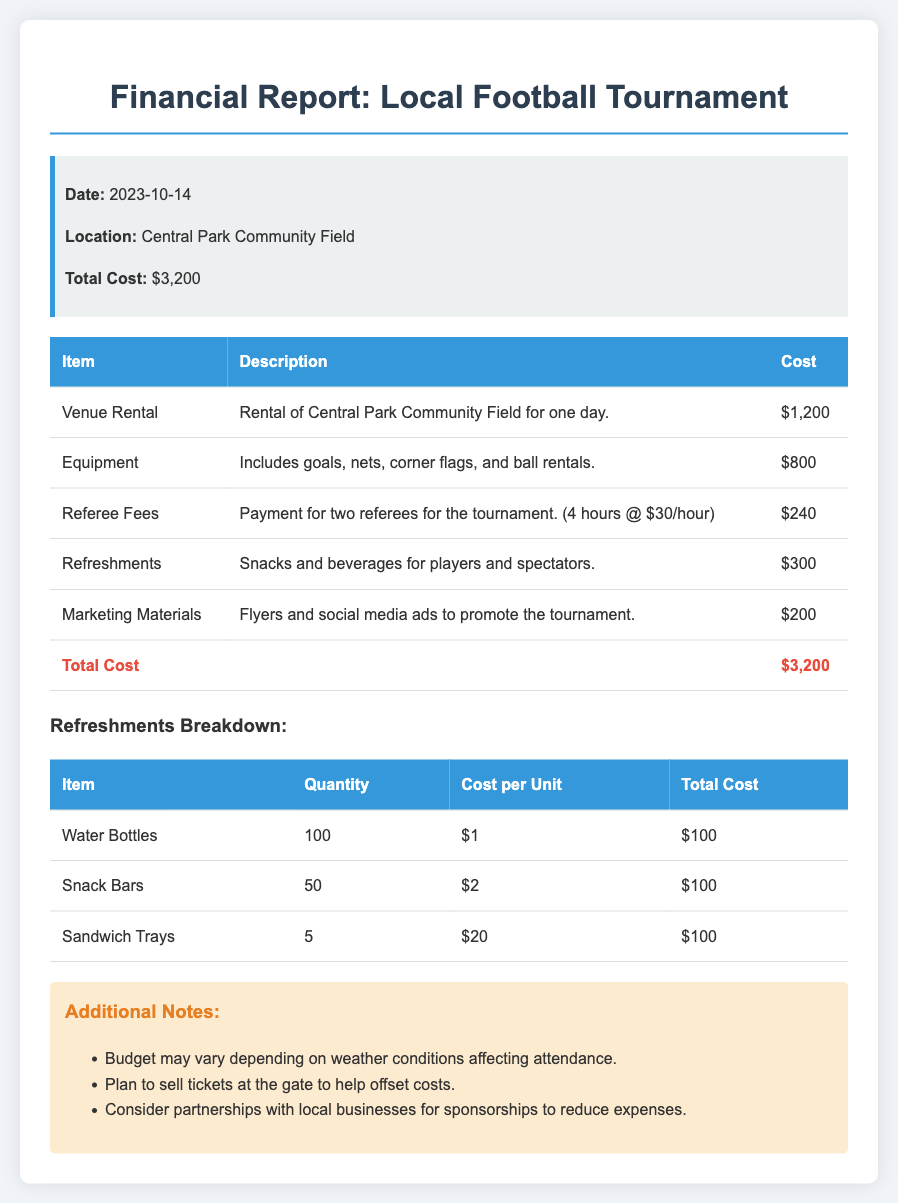What is the date of the tournament? The date of the tournament is provided in the document under the Date section.
Answer: 2023-10-14 What is the total cost of hosting the tournament? The total cost is mentioned as the total amount at the beginning of the report.
Answer: $3,200 How much did the venue rental cost? The cost for venue rental is listed in the first item of the cost table.
Answer: $1,200 How many referees were paid for the tournament? The number of referees is included in the description of the referee fees.
Answer: Two What was the cost of equipment rentals? The cost of equipment is specified in the cost breakdown of the report.
Answer: $800 What was the total quantity of water bottles ordered? The quantity of water bottles can be found in the refreshments breakdown table.
Answer: 100 What items were included in the refreshments category? The refreshment items are listed in the refreshments breakdown table with their respective quantities.
Answer: Water Bottles, Snack Bars, Sandwich Trays How much was spent on marketing materials? The cost of marketing materials is mentioned in the cost table under Marketing Materials.
Answer: $200 What is an additional note regarding the budget? Additional notes regarding the budget are provided towards the bottom of the report.
Answer: Budget may vary depending on weather conditions affecting attendance 